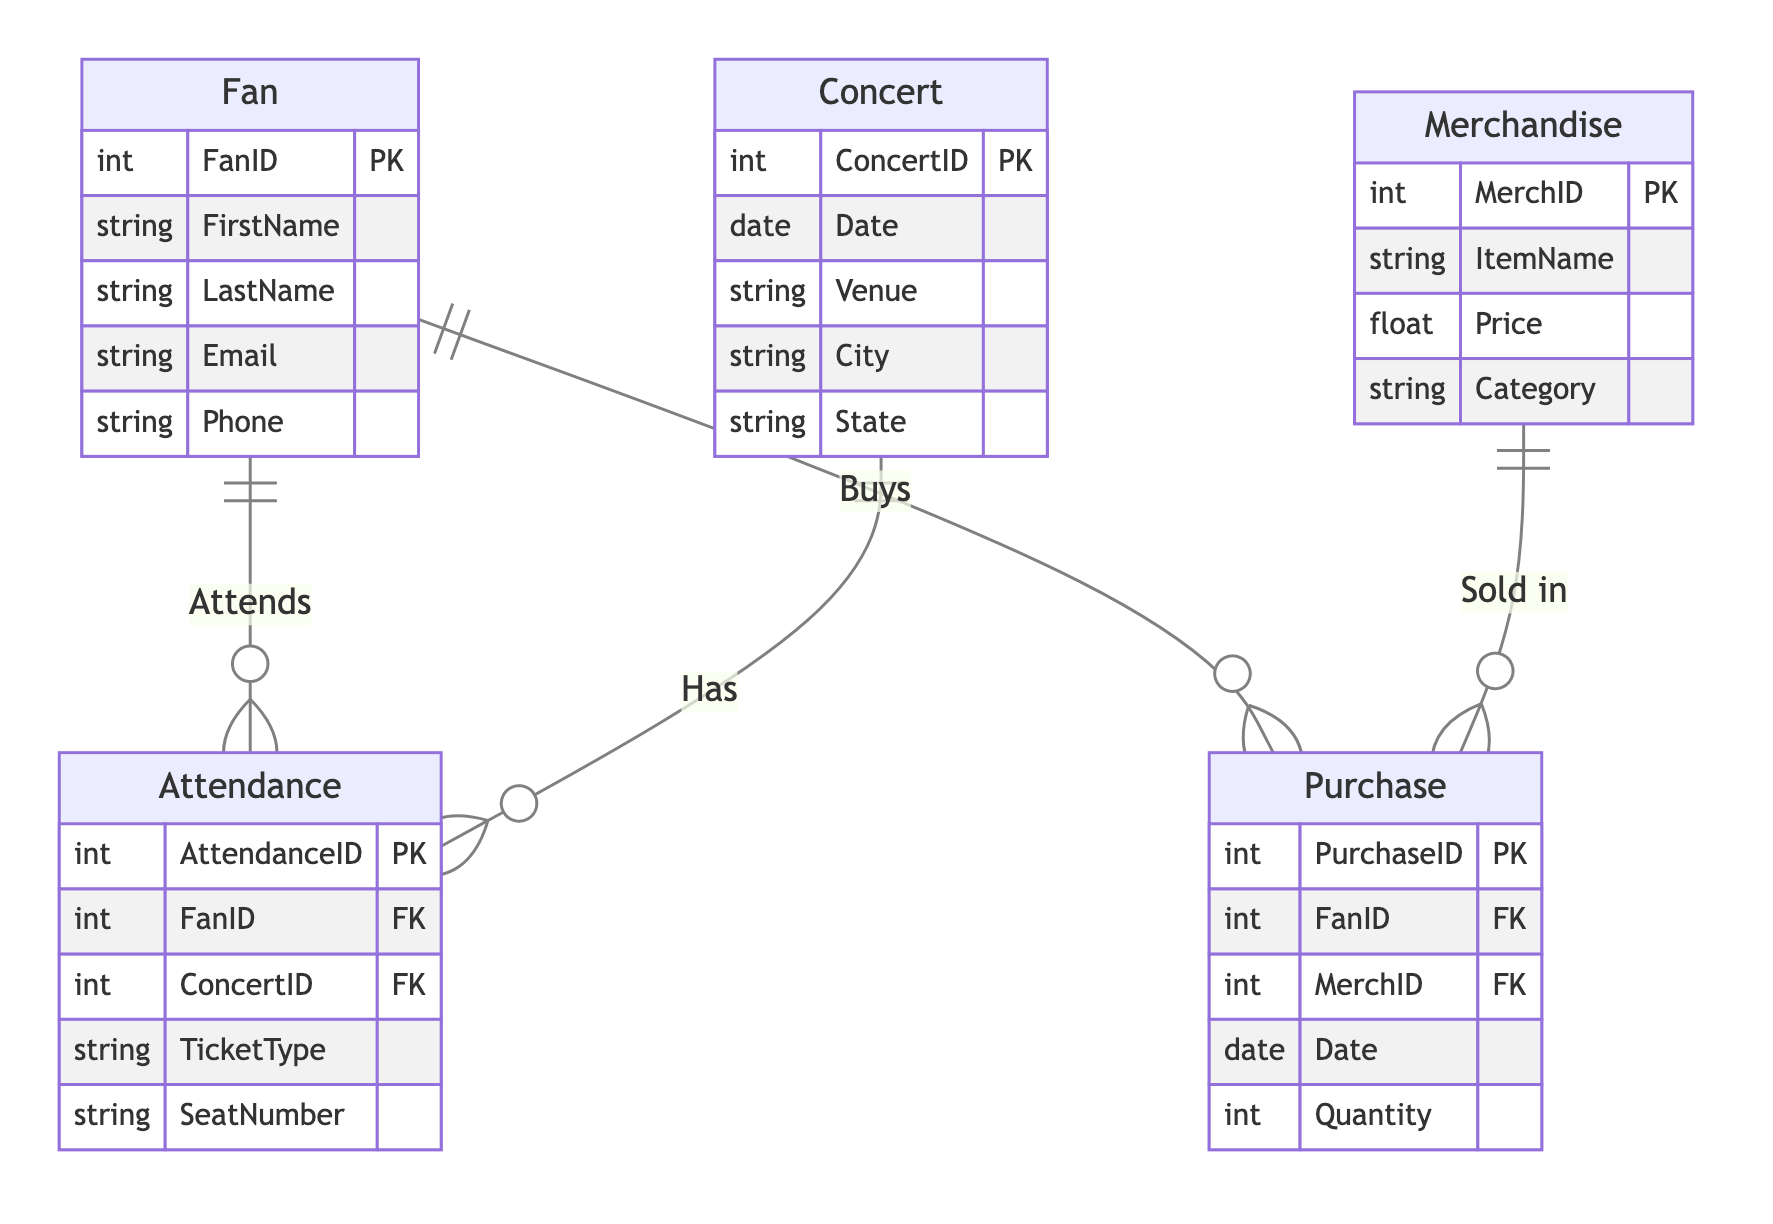What entities are present in the diagram? The diagram contains five entities: Fan, Concert, Attendance, Merchandise, and Purchase. This information can be found by looking at the list of entities defined in the diagram.
Answer: Fan, Concert, Attendance, Merchandise, Purchase How many relationships are defined in the diagram? There are two relationships defined in the diagram: "Attends" and "Buys." This can be determined by counting the relationships listed at the end of the diagram.
Answer: 2 What type of relationship exists between Fan and Concert? The relationship between Fan and Concert is a many-to-many relationship as indicated in the "Relationships" section that describes it as “Link between fans and concerts they attend” with the note about it being through Attendance.
Answer: many-to-many What is the primary key of the Merchandise entity? The primary key of the Merchandise entity is MerchID, as indicated by the notation "PK" next to it in the entity's definition.
Answer: MerchID How is the Purchase entity related to the Fan entity? The Purchase entity is related to the Fan entity through a many-to-many relationship, called "Buys," which indicates that multiple fans can purchase multiple merchandise items as shown in the relationships section.
Answer: many-to-many Which entity contains the attribute 'SeatNumber'? The Attendance entity contains the attribute 'SeatNumber' as listed in its definitions. This attribute is specifically related to tickets for concerts.
Answer: Attendance What does the Attendance entity specifically link to? The Attendance entity specifically links Fans to Concerts they attend and includes additional details like TicketType and SeatNumber. This function can be inferred by its role in the "Attends" relationship in the diagram.
Answer: Fans and Concerts Which attribute in the Merchandise entity could help identify the type of item? The attribute 'Category' in the Merchandise entity helps identify the type of item, as it categorizes merchandise for better organization and understanding.
Answer: Category What does the Purchase entity track alongside the FanID? The Purchase entity tracks the MerchID alongside the FanID, indicating which merchandise a fan has purchased. This is evident from the attributes defined in the Purchase entity.
Answer: MerchID 